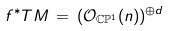<formula> <loc_0><loc_0><loc_500><loc_500>f ^ { * } T M \, = \, ( { \mathcal { O } } _ { { \mathbb { C } } { \mathbb { P } } ^ { 1 } } ( n ) ) ^ { \oplus d }</formula> 